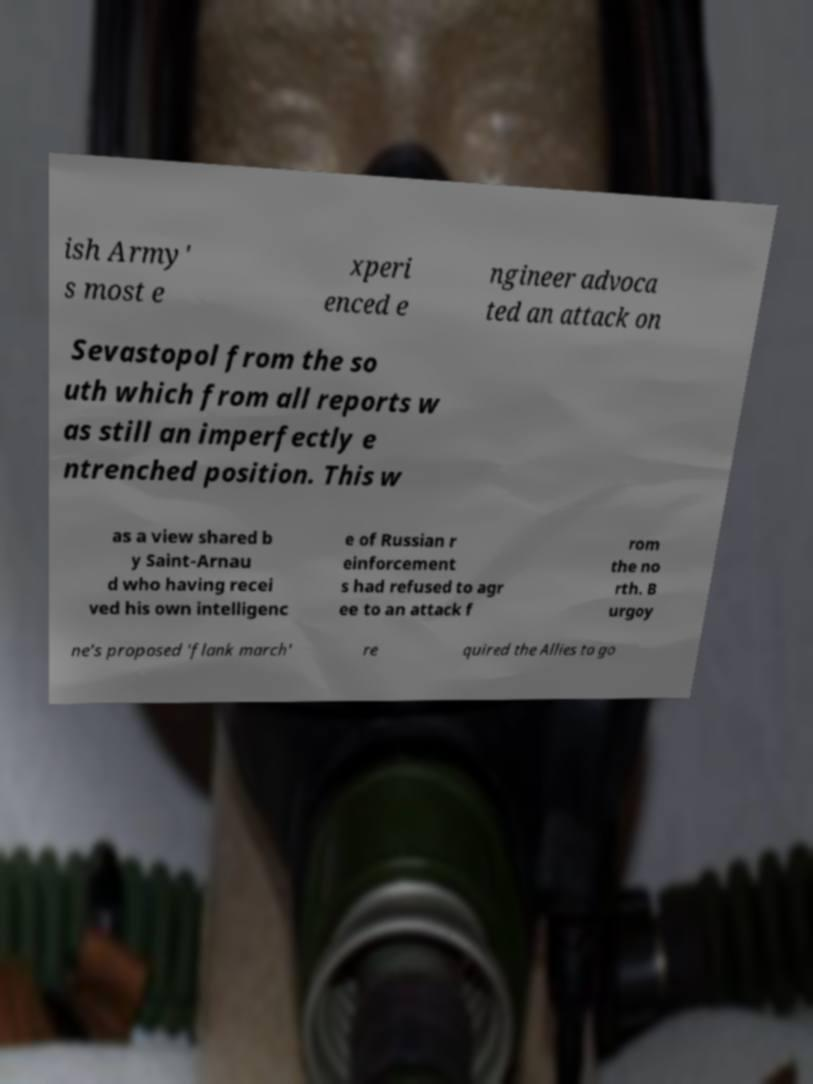For documentation purposes, I need the text within this image transcribed. Could you provide that? ish Army' s most e xperi enced e ngineer advoca ted an attack on Sevastopol from the so uth which from all reports w as still an imperfectly e ntrenched position. This w as a view shared b y Saint-Arnau d who having recei ved his own intelligenc e of Russian r einforcement s had refused to agr ee to an attack f rom the no rth. B urgoy ne's proposed 'flank march' re quired the Allies to go 